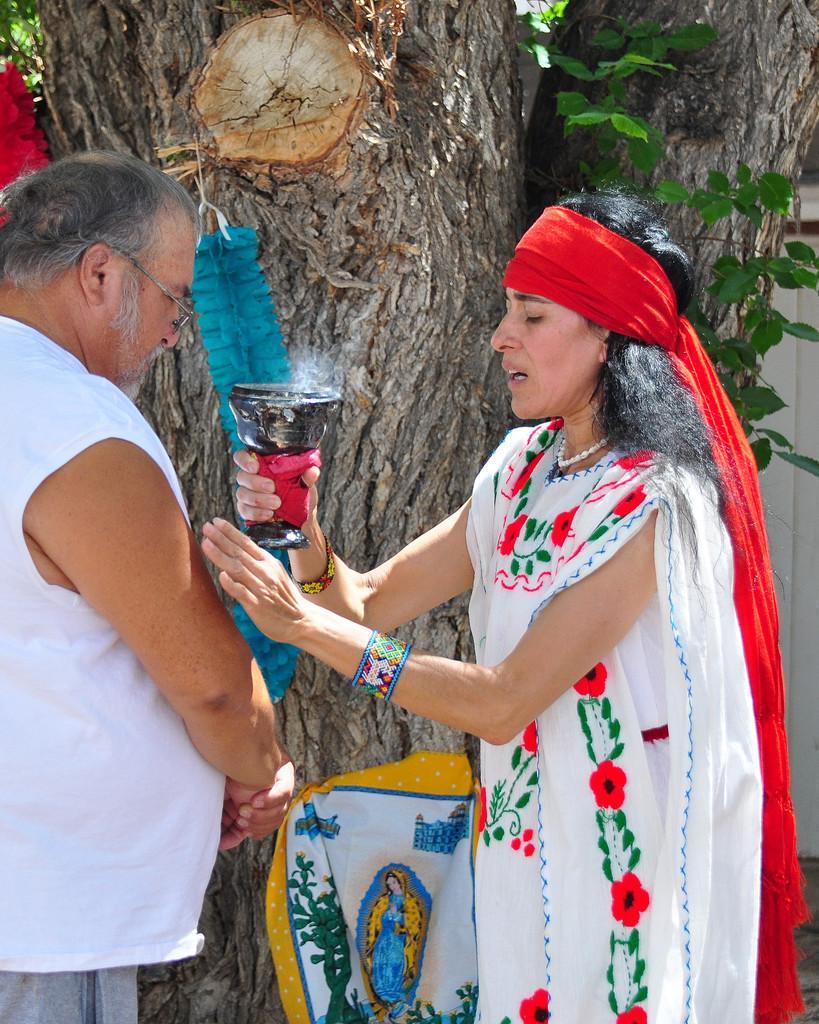In one or two sentences, can you explain what this image depicts? In this picture there are persons standing in the front. The woman on the right side is standing and holding an object which is black in colour. In the background there is a tree and on the tree there is a cloth and there is a white colour wall behind the tree. 